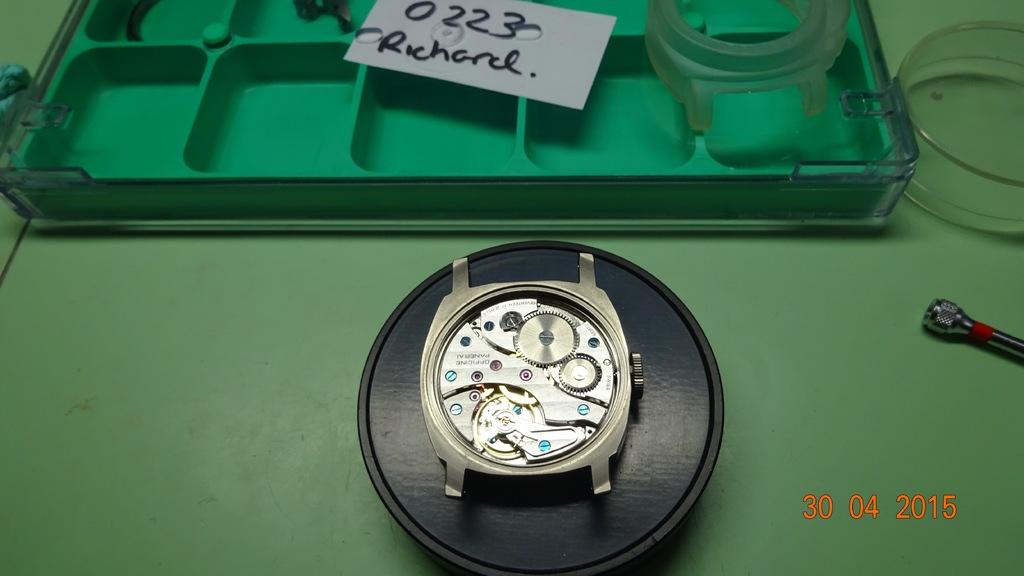<image>
Describe the image concisely. An incomplete watch sits on a table with a note addressed to Richard sitting above it. 